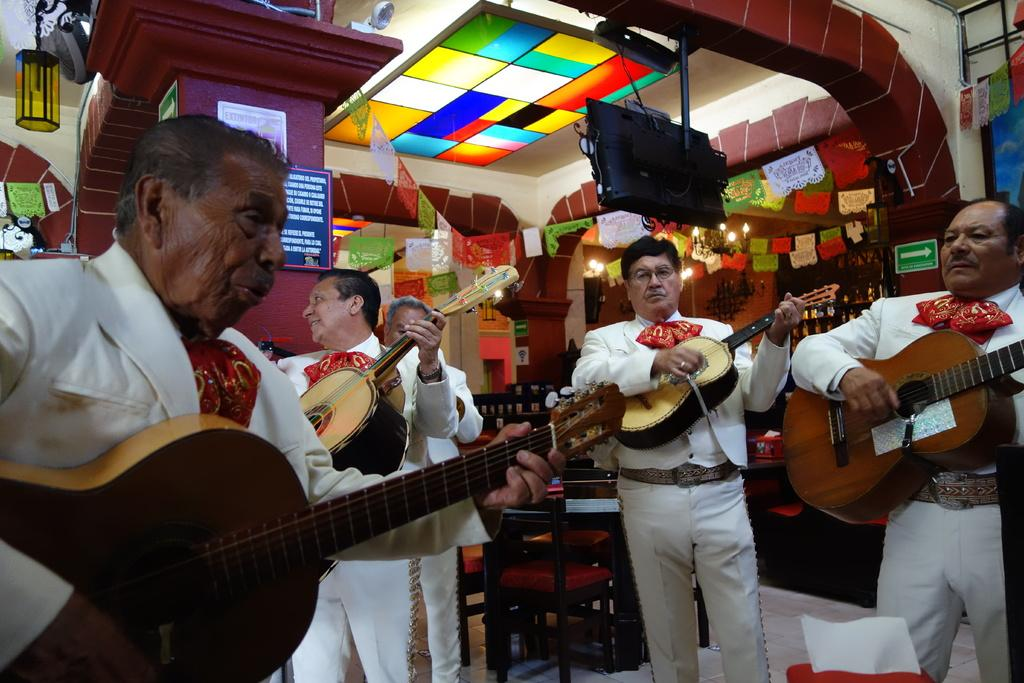How many people are in the image? There are four men in the image. What are the men doing in the image? The men are playing guitars. What type of furniture is present in the image? There are chairs and tables in the image. What electronic device can be seen in the image? There is a television in the image. What type of silk fabric is draped over the airplane in the image? There is no airplane or silk fabric present in the image. What type of notebook is being used by the men while playing guitars? There is no notebook visible in the image; the men are playing guitars without any visible writing or note-taking materials. 